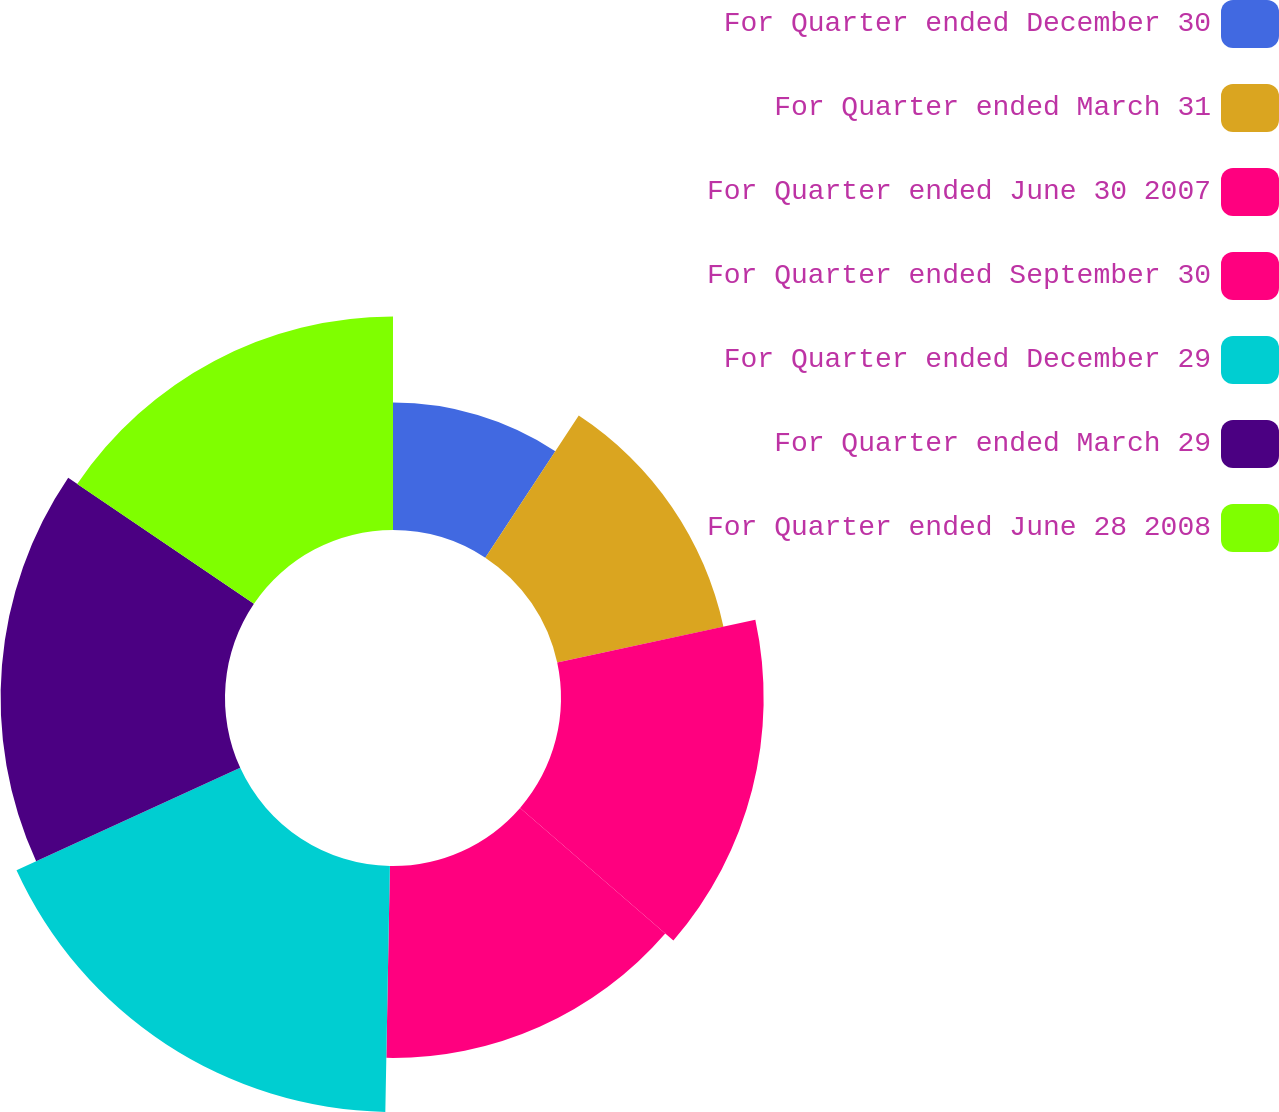Convert chart. <chart><loc_0><loc_0><loc_500><loc_500><pie_chart><fcel>For Quarter ended December 30<fcel>For Quarter ended March 31<fcel>For Quarter ended June 30 2007<fcel>For Quarter ended September 30<fcel>For Quarter ended December 29<fcel>For Quarter ended March 29<fcel>For Quarter ended June 28 2008<nl><fcel>9.26%<fcel>12.36%<fcel>14.73%<fcel>13.95%<fcel>17.88%<fcel>16.31%<fcel>15.52%<nl></chart> 